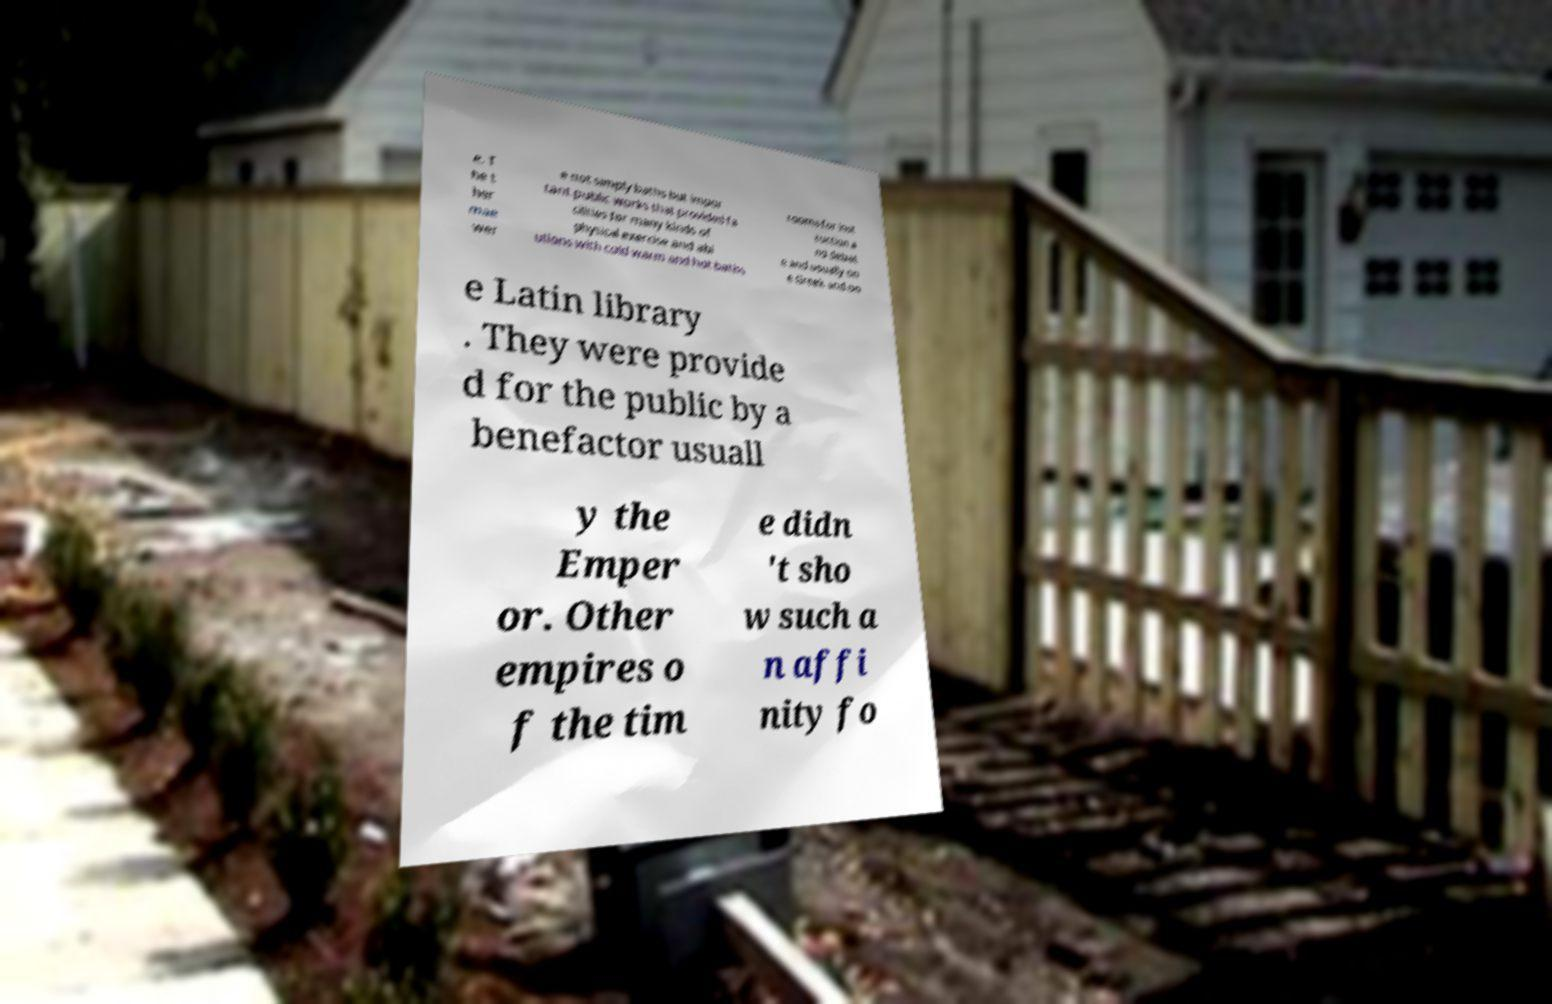Can you read and provide the text displayed in the image?This photo seems to have some interesting text. Can you extract and type it out for me? e. T he t her mae wer e not simply baths but impor tant public works that provided fa cilities for many kinds of physical exercise and abl utions with cold warm and hot baths rooms for inst ruction a nd debat e and usually on e Greek and on e Latin library . They were provide d for the public by a benefactor usuall y the Emper or. Other empires o f the tim e didn 't sho w such a n affi nity fo 